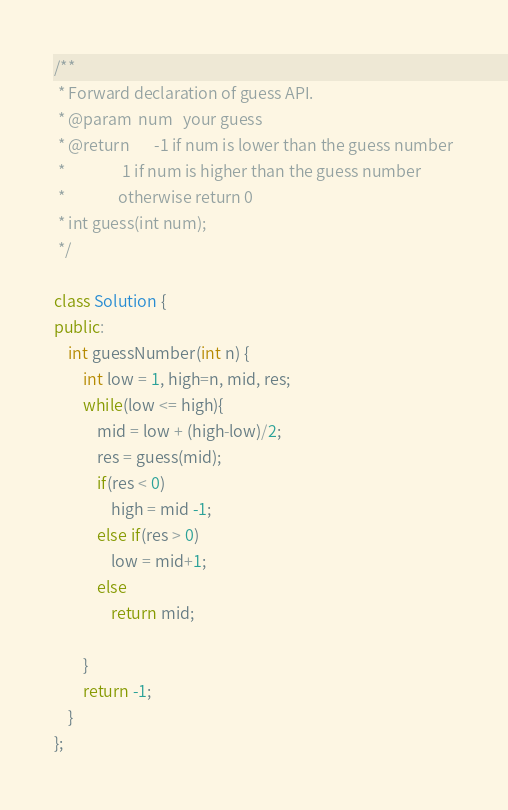<code> <loc_0><loc_0><loc_500><loc_500><_C++_>/** 
 * Forward declaration of guess API.
 * @param  num   your guess
 * @return 	     -1 if num is lower than the guess number
 *			      1 if num is higher than the guess number
 *               otherwise return 0
 * int guess(int num);
 */

class Solution {
public:
    int guessNumber(int n) {
        int low = 1, high=n, mid, res;
        while(low <= high){
            mid = low + (high-low)/2;
            res = guess(mid);
            if(res < 0)
                high = mid -1;
            else if(res > 0)
                low = mid+1;
            else
                return mid;
            
        }
        return -1;  
    }
};</code> 